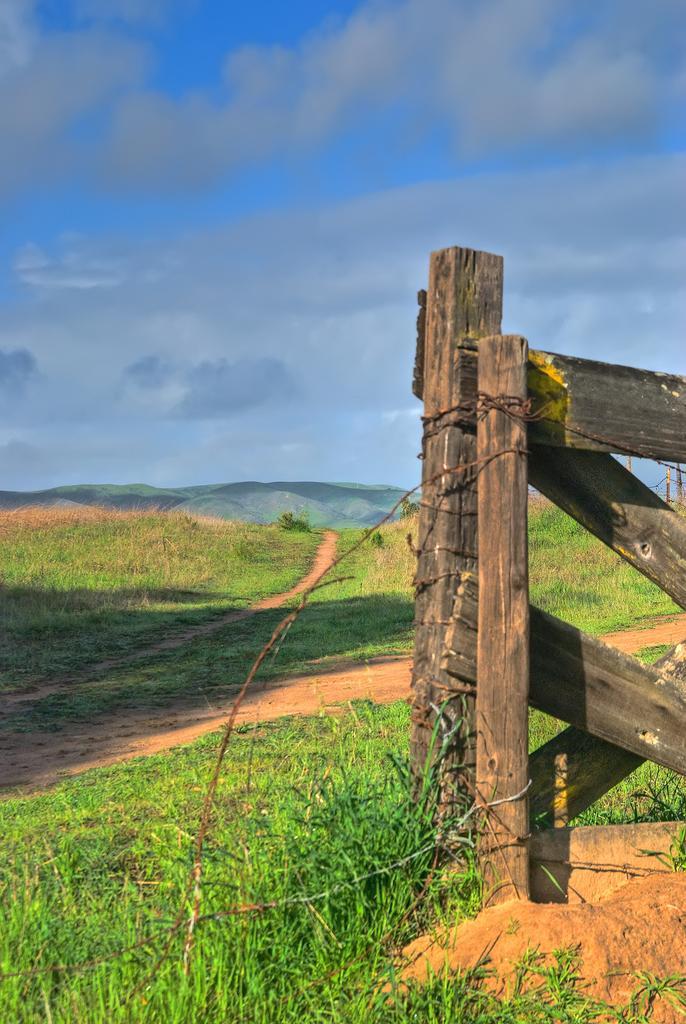How would you summarize this image in a sentence or two? In this picture I can observe wooden railing on the right side. I can observe some grass on the ground. In the background there are clouds in the sky. 